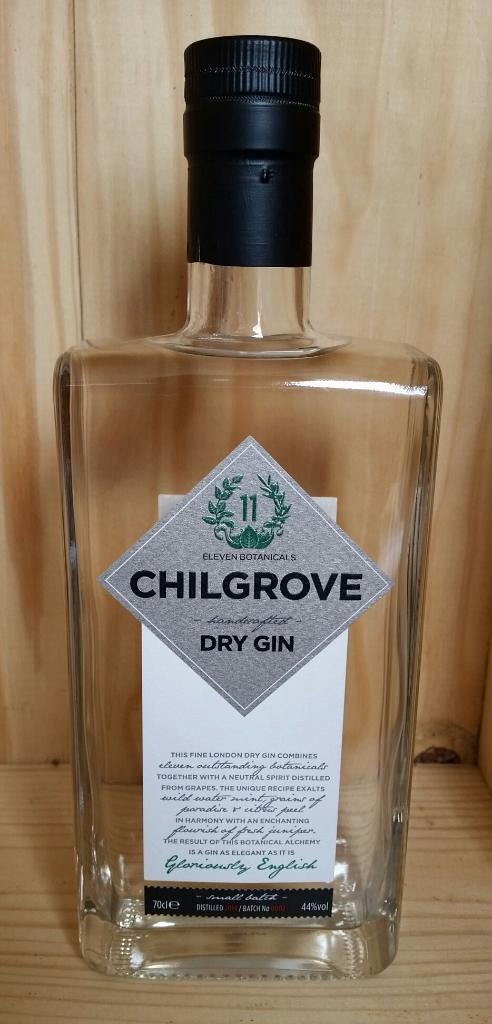<image>
Provide a brief description of the given image. A bottle of Chilgrove Dry Gin sits on a display case 